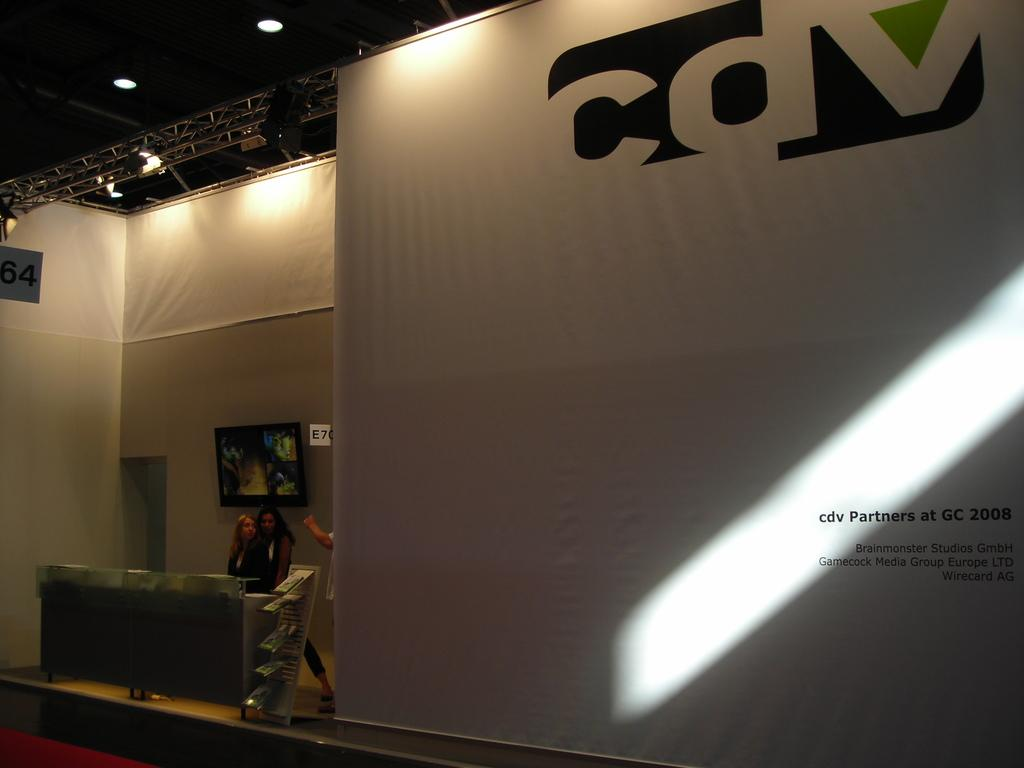<image>
Write a terse but informative summary of the picture. One of the groups CDV partners with at the GC 2008 is Wirecard AG. 